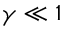<formula> <loc_0><loc_0><loc_500><loc_500>\gamma \ll 1</formula> 